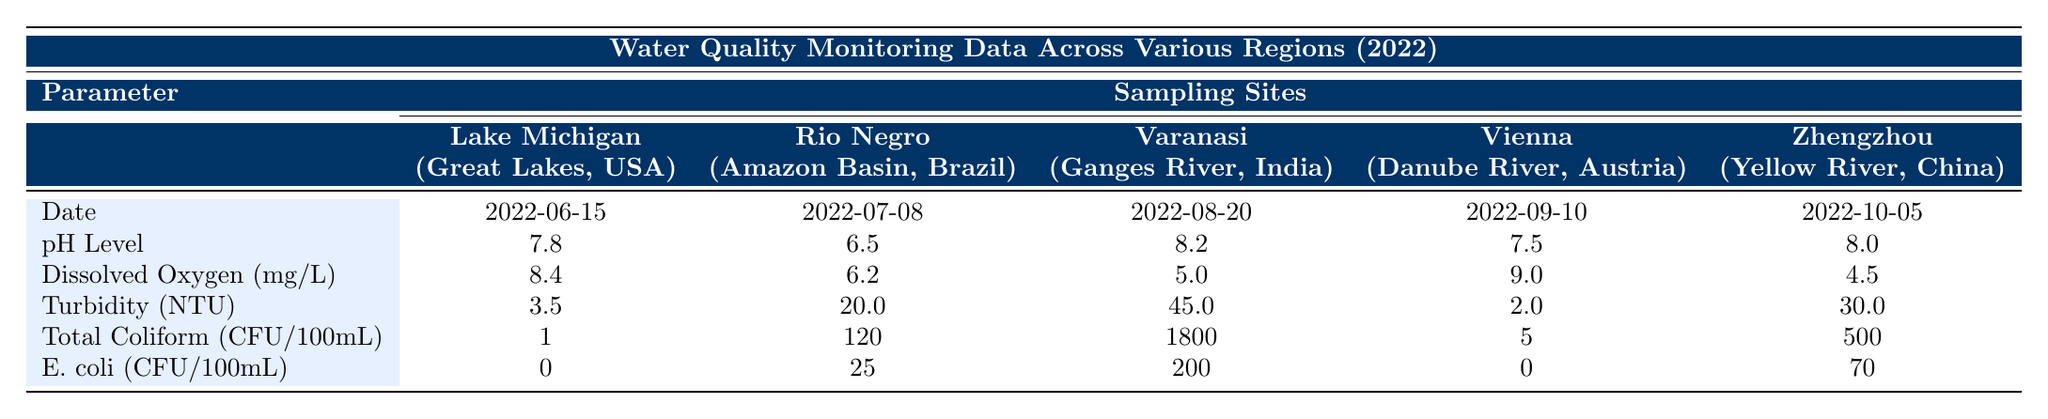What is the pH level of the water in Lake Michigan? The table shows the parameter for pH level under the sampling site Lake Michigan, where it is listed as 7.8.
Answer: 7.8 Which region has the highest turbidity measurement? By examining the turbidity values from the table, the turbidity for Varanasi is 45.0, which is higher than the other regions, indicating it has the highest turbidity.
Answer: Varanasi Are there any E. coli readings of zero among the sampling sites? Looking at the table, Lake Michigan and Vienna both have E. coli readings of 0, confirming that there are sites with no detected E. coli.
Answer: Yes What is the dissolved oxygen level in the Yellow River? The dissolved oxygen level for the Yellow River at Zhengzhou is specified in the table as 4.5 mg/L.
Answer: 4.5 mg/L What is the average pH level across the regions listed? To find the average pH level, we add the pH levels from each region: (7.8 + 6.5 + 8.2 + 7.5 + 8.0) = 38.0. Then divide by the number of regions, which is 5. So, 38.0 / 5 = 7.6.
Answer: 7.6 Is the total coliform level in Rio Negro greater than 100? The table lists the total coliform level in Rio Negro as 120, which confirms it is greater than 100.
Answer: Yes Which region has the lowest dissolved oxygen level and what is that level? The table indicates that the region with the lowest dissolved oxygen level is the Yellow River at Zhengzhou, with a measurement of 4.5 mg/L.
Answer: Yellow River, 4.5 mg/L How does the turbidity of the Danube River compare to that of the Amazon Basin? The table shows that turbidity for the Danube River in Vienna is 2.0 and for the Amazon Basin in Rio Negro is 20.0. Since 2.0 is less than 20.0, the Danube River has lower turbidity than the Amazon Basin.
Answer: Lower What is the difference in total coliform levels between Varanasi and Lake Michigan? From the table, Varanasi has a total coliform level of 1800, while Lake Michigan has 1. To find the difference, we subtract: 1800 - 1 = 1799.
Answer: 1799 